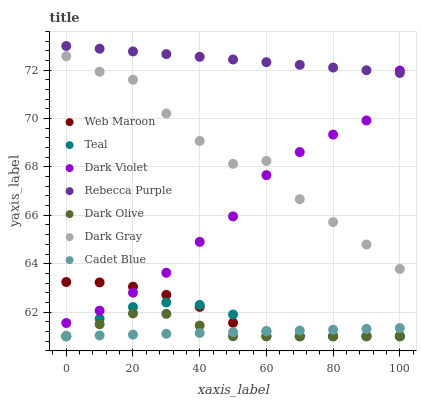Does Cadet Blue have the minimum area under the curve?
Answer yes or no. Yes. Does Rebecca Purple have the maximum area under the curve?
Answer yes or no. Yes. Does Dark Olive have the minimum area under the curve?
Answer yes or no. No. Does Dark Olive have the maximum area under the curve?
Answer yes or no. No. Is Cadet Blue the smoothest?
Answer yes or no. Yes. Is Dark Gray the roughest?
Answer yes or no. Yes. Is Dark Olive the smoothest?
Answer yes or no. No. Is Dark Olive the roughest?
Answer yes or no. No. Does Cadet Blue have the lowest value?
Answer yes or no. Yes. Does Dark Violet have the lowest value?
Answer yes or no. No. Does Rebecca Purple have the highest value?
Answer yes or no. Yes. Does Dark Olive have the highest value?
Answer yes or no. No. Is Cadet Blue less than Rebecca Purple?
Answer yes or no. Yes. Is Rebecca Purple greater than Dark Olive?
Answer yes or no. Yes. Does Cadet Blue intersect Web Maroon?
Answer yes or no. Yes. Is Cadet Blue less than Web Maroon?
Answer yes or no. No. Is Cadet Blue greater than Web Maroon?
Answer yes or no. No. Does Cadet Blue intersect Rebecca Purple?
Answer yes or no. No. 